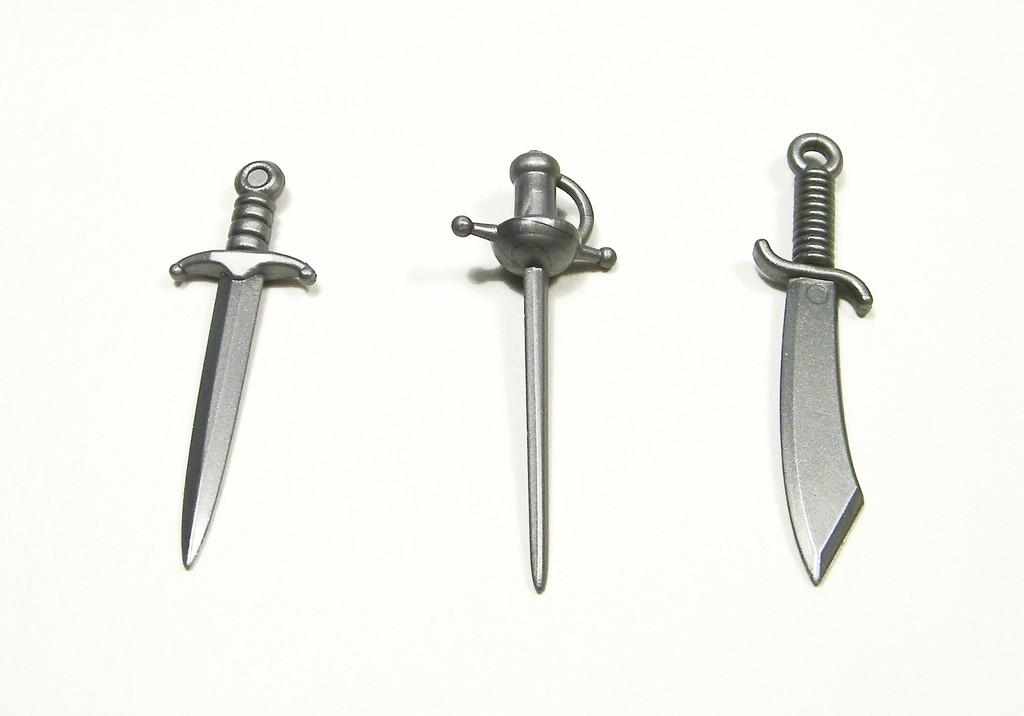How many swords are present in the image? There are three swords in the image. Where are the swords located in the image? The swords are kept on the floor. What type of carriage can be seen in the image? There is no carriage present in the image; it only features three swords on the floor. 